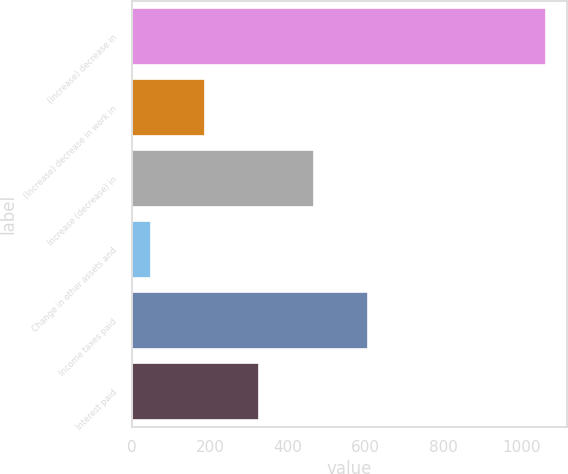<chart> <loc_0><loc_0><loc_500><loc_500><bar_chart><fcel>(Increase) decrease in<fcel>(Increase) decrease in work in<fcel>Increase (decrease) in<fcel>Change in other assets and<fcel>Income taxes paid<fcel>Interest paid<nl><fcel>1063.6<fcel>187.84<fcel>466.92<fcel>48.3<fcel>606.46<fcel>327.38<nl></chart> 